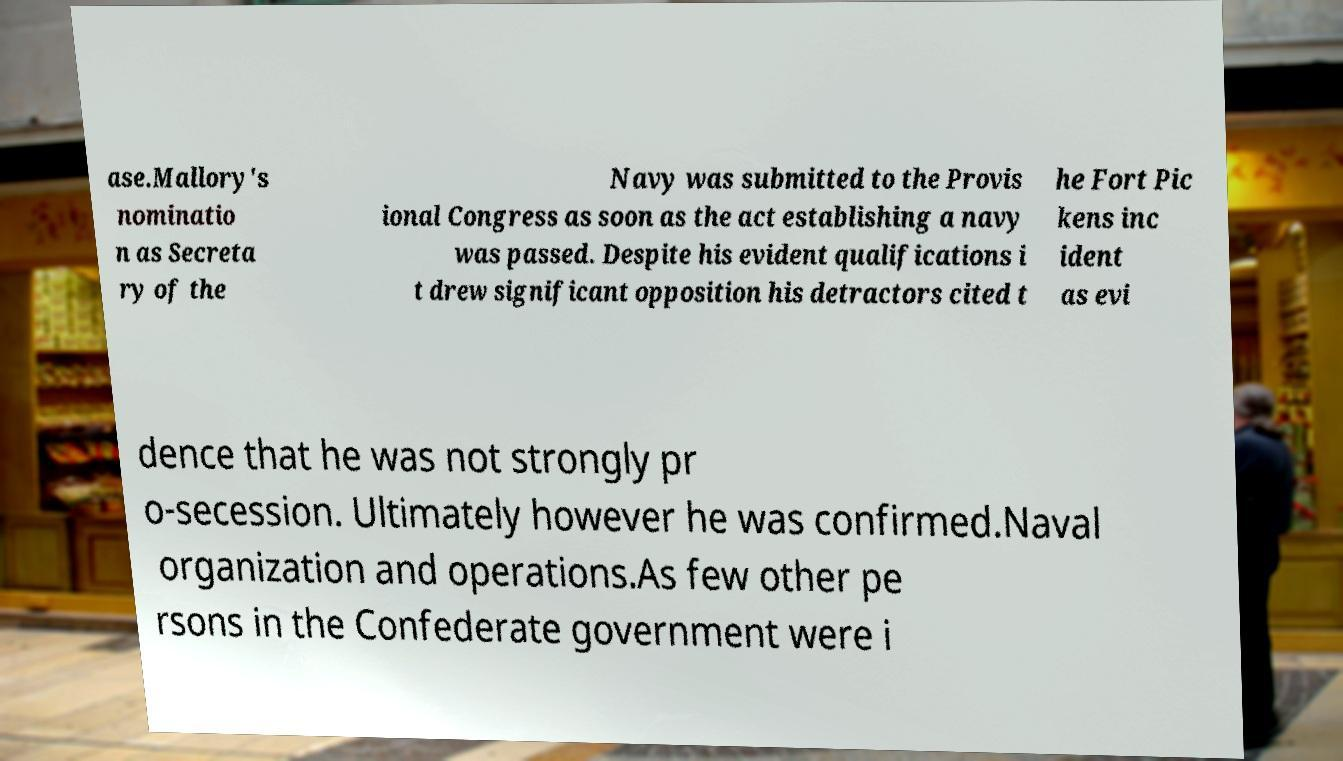Can you accurately transcribe the text from the provided image for me? ase.Mallory's nominatio n as Secreta ry of the Navy was submitted to the Provis ional Congress as soon as the act establishing a navy was passed. Despite his evident qualifications i t drew significant opposition his detractors cited t he Fort Pic kens inc ident as evi dence that he was not strongly pr o-secession. Ultimately however he was confirmed.Naval organization and operations.As few other pe rsons in the Confederate government were i 